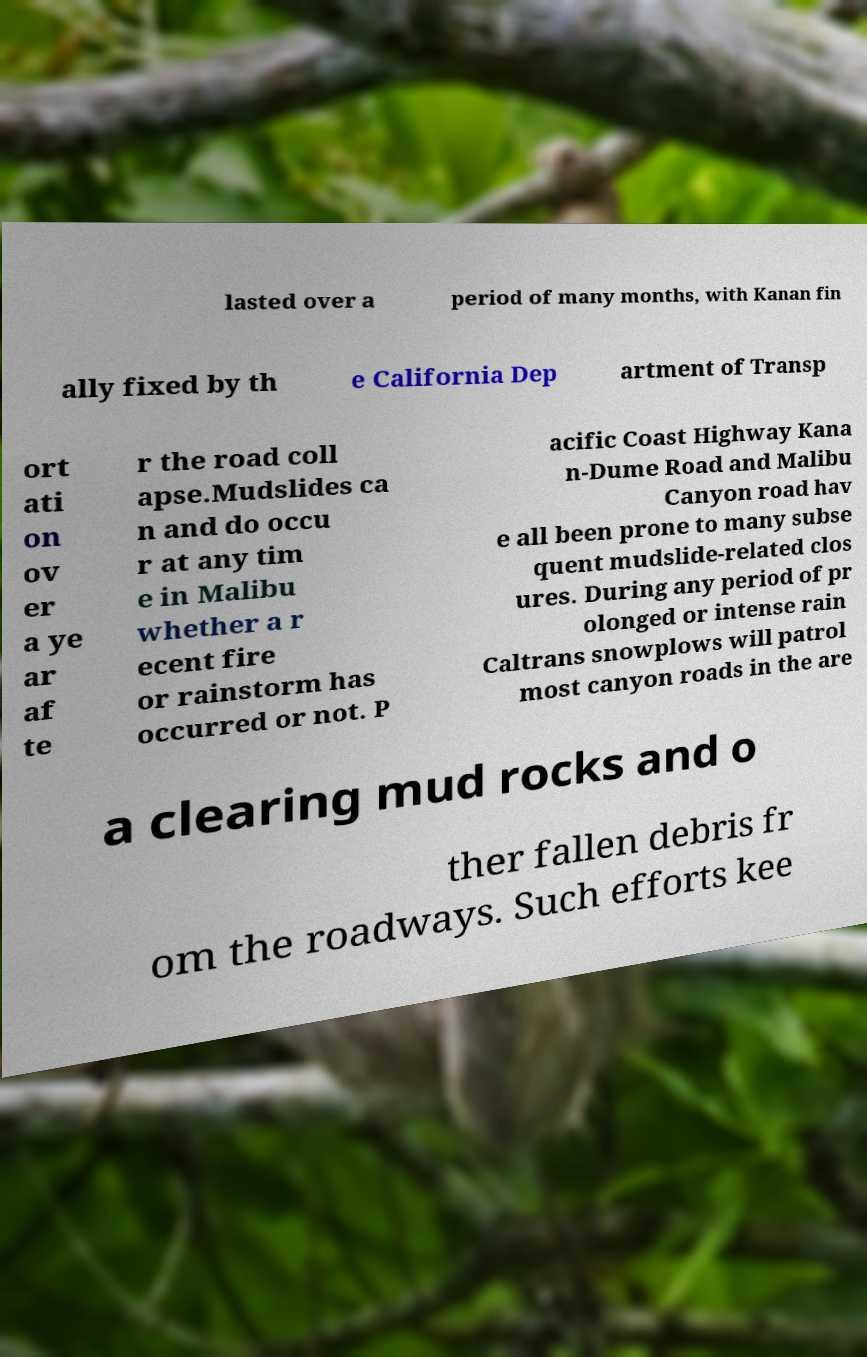Can you read and provide the text displayed in the image?This photo seems to have some interesting text. Can you extract and type it out for me? lasted over a period of many months, with Kanan fin ally fixed by th e California Dep artment of Transp ort ati on ov er a ye ar af te r the road coll apse.Mudslides ca n and do occu r at any tim e in Malibu whether a r ecent fire or rainstorm has occurred or not. P acific Coast Highway Kana n-Dume Road and Malibu Canyon road hav e all been prone to many subse quent mudslide-related clos ures. During any period of pr olonged or intense rain Caltrans snowplows will patrol most canyon roads in the are a clearing mud rocks and o ther fallen debris fr om the roadways. Such efforts kee 